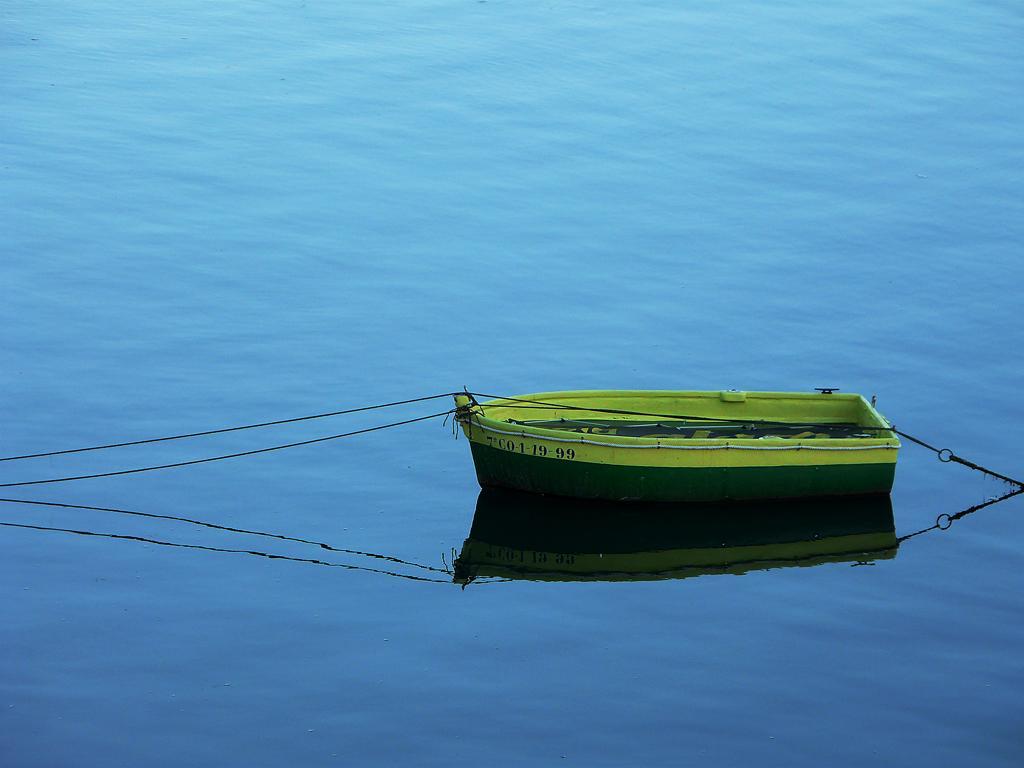Please provide a concise description of this image. This image consists of a boat in green color. At the bottom, there is water. The boat is tied with a rope. 